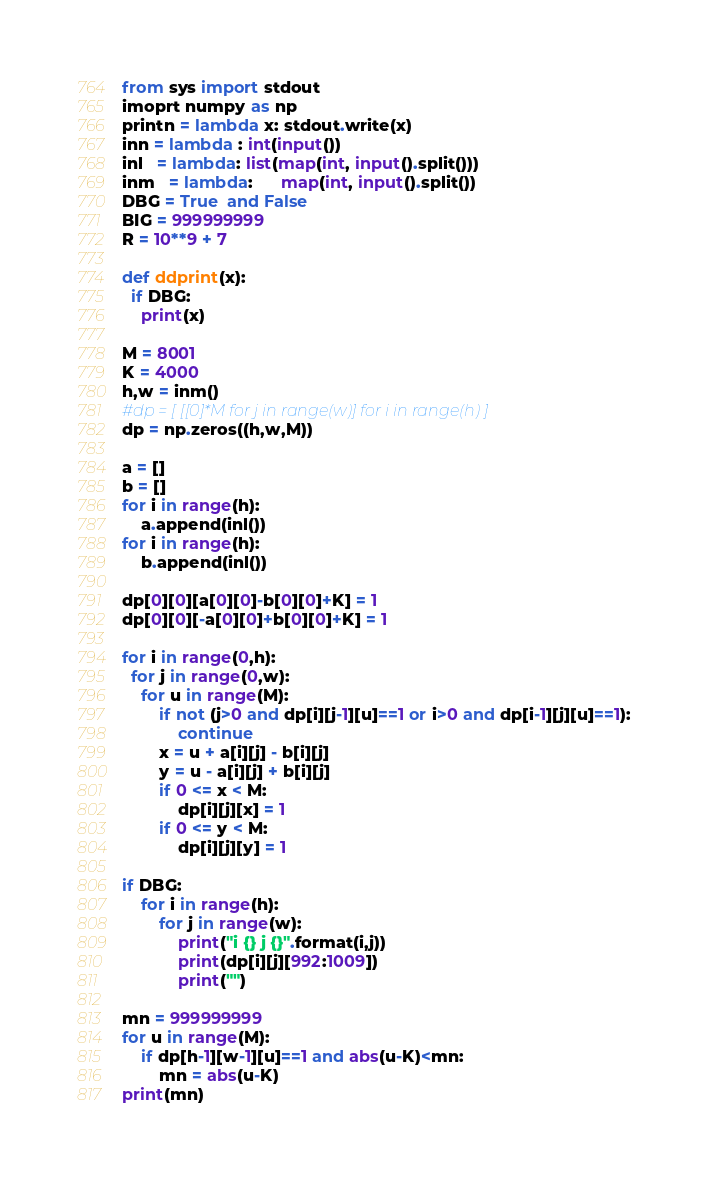Convert code to text. <code><loc_0><loc_0><loc_500><loc_500><_Python_>from sys import stdout
imoprt numpy as np
printn = lambda x: stdout.write(x)
inn = lambda : int(input())
inl   = lambda: list(map(int, input().split()))
inm   = lambda:      map(int, input().split())
DBG = True  and False
BIG = 999999999
R = 10**9 + 7

def ddprint(x):
  if DBG:
    print(x)

M = 8001
K = 4000
h,w = inm()
#dp = [ [[0]*M for j in range(w)] for i in range(h) ]
dp = np.zeros((h,w,M))

a = []
b = []
for i in range(h):
    a.append(inl())
for i in range(h):
    b.append(inl())

dp[0][0][a[0][0]-b[0][0]+K] = 1
dp[0][0][-a[0][0]+b[0][0]+K] = 1

for i in range(0,h):
  for j in range(0,w):
    for u in range(M):
        if not (j>0 and dp[i][j-1][u]==1 or i>0 and dp[i-1][j][u]==1):
            continue
        x = u + a[i][j] - b[i][j]
        y = u - a[i][j] + b[i][j]
        if 0 <= x < M:
            dp[i][j][x] = 1
        if 0 <= y < M:
            dp[i][j][y] = 1

if DBG:
    for i in range(h):
        for j in range(w):
            print("i {} j {}".format(i,j))
            print(dp[i][j][992:1009])
            print("")

mn = 999999999
for u in range(M):
    if dp[h-1][w-1][u]==1 and abs(u-K)<mn:
        mn = abs(u-K)
print(mn)
</code> 